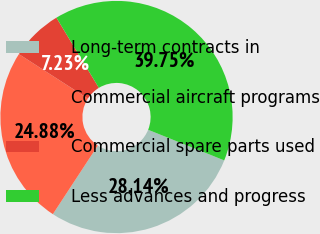<chart> <loc_0><loc_0><loc_500><loc_500><pie_chart><fcel>Long-term contracts in<fcel>Commercial aircraft programs<fcel>Commercial spare parts used<fcel>Less advances and progress<nl><fcel>28.14%<fcel>24.88%<fcel>7.23%<fcel>39.75%<nl></chart> 